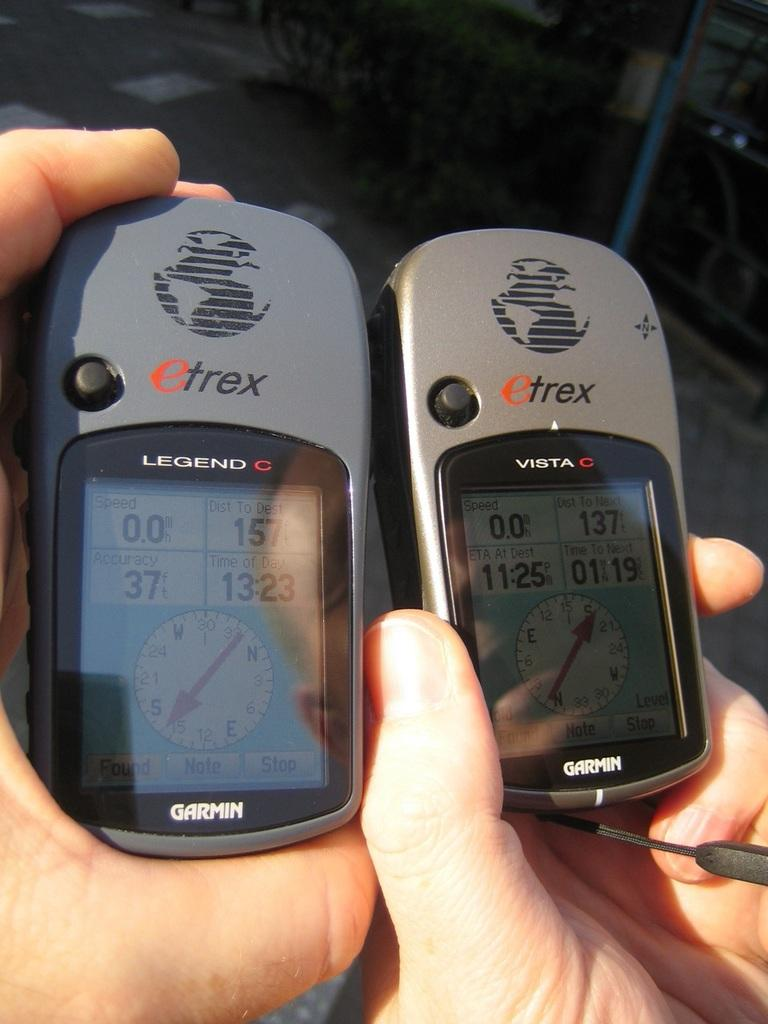<image>
Render a clear and concise summary of the photo. Garmin Etrex Legend and Vista C device that tracks distance and direction. 